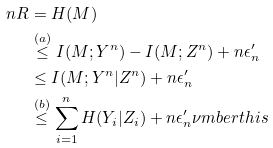Convert formula to latex. <formula><loc_0><loc_0><loc_500><loc_500>n R & = H ( M ) \\ & \stackrel { ( a ) } \leq I ( M ; Y ^ { n } ) - I ( M ; Z ^ { n } ) + n \epsilon ^ { \prime } _ { n } \\ & \leq I ( M ; Y ^ { n } | Z ^ { n } ) + n \epsilon ^ { \prime } _ { n } \\ & \stackrel { ( b ) } \leq \sum _ { i = 1 } ^ { n } H ( Y _ { i } | Z _ { i } ) + n \epsilon ^ { \prime } _ { n } \nu m b e r t h i s</formula> 